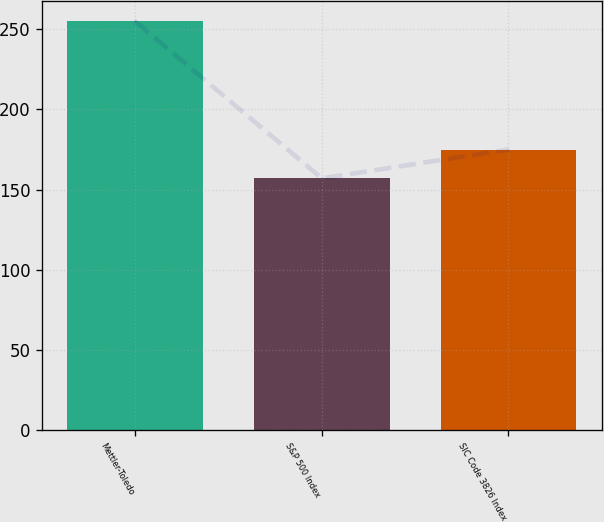Convert chart to OTSL. <chart><loc_0><loc_0><loc_500><loc_500><bar_chart><fcel>Mettler-Toledo<fcel>S&P 500 Index<fcel>SIC Code 3826 Index<nl><fcel>255<fcel>157<fcel>175<nl></chart> 